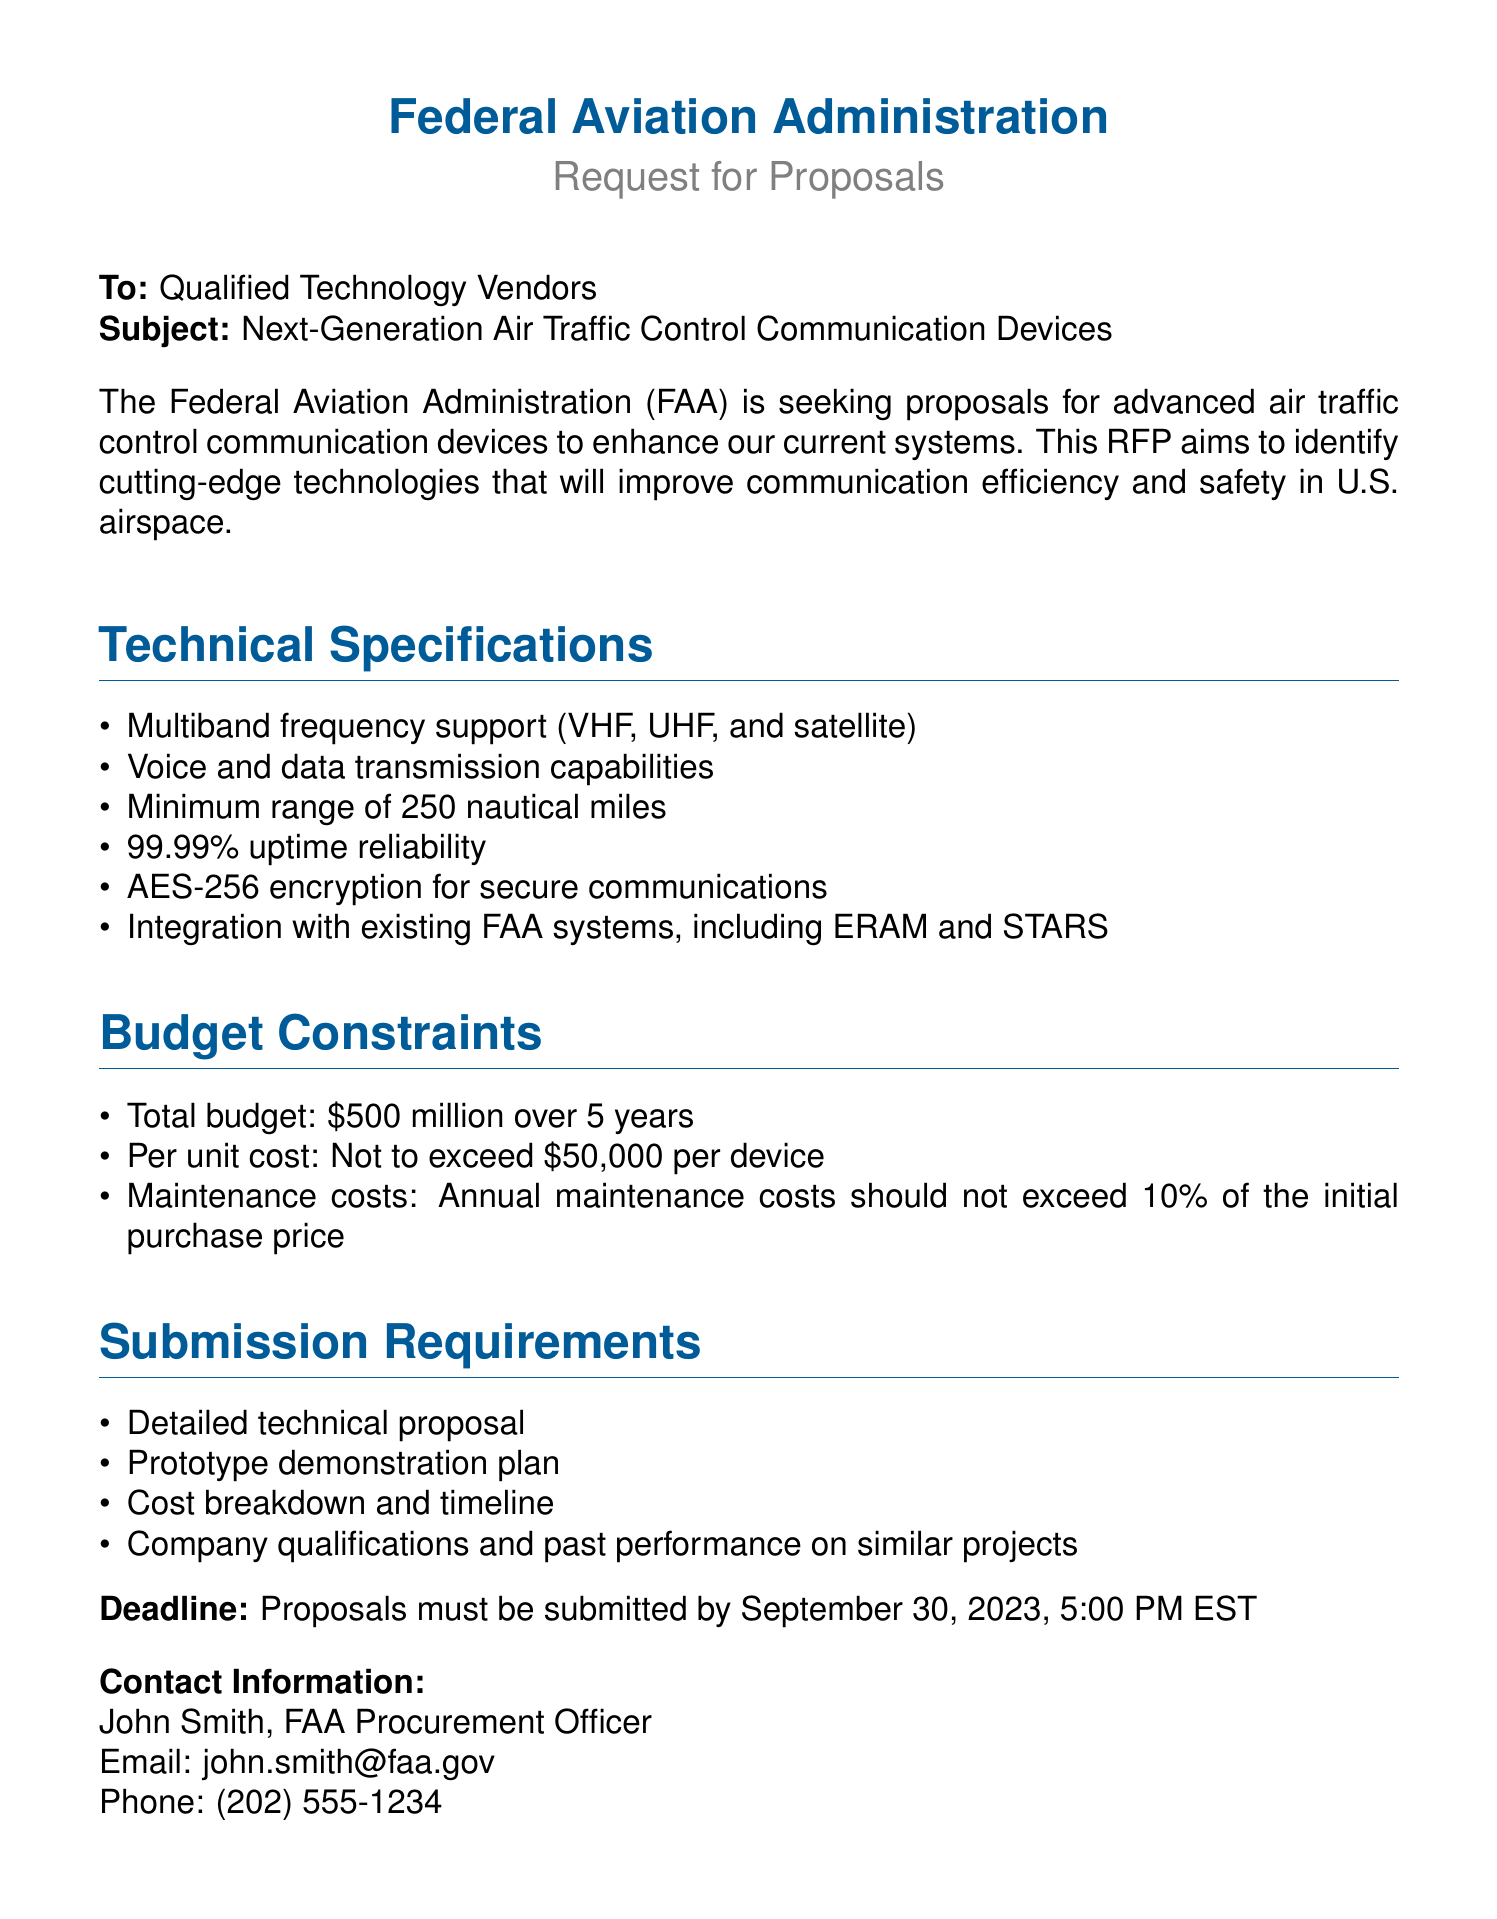What is the total budget for the project? The total budget for the project is stated in the document under the budget constraints section.
Answer: $500 million over 5 years What is the minimum range required for the communication devices? The minimum range is specified in the technical specifications section of the document.
Answer: 250 nautical miles What encryption standard must be used? The encryption standard is mentioned in the technical specifications as part of the secure communications requirements.
Answer: AES-256 Who is the contact person for this RFP? The contact person's name is provided at the end of the document under contact information.
Answer: John Smith What is the deadline for proposal submission? The deadline for submission is stated clearly in the document.
Answer: September 30, 2023, 5:00 PM EST What is the maximum per unit cost for the devices? The maximum cost per unit is detailed in the budget constraints section.
Answer: $50,000 per device What is the annual maintenance cost limit? The annual maintenance cost limit is specified in the budget constraints section of the document.
Answer: 10% of the initial purchase price Which existing FAA systems must the new devices integrate with? The existing systems mentioned in the technical specifications provide insight into the integration requirements.
Answer: ERAM and STARS 